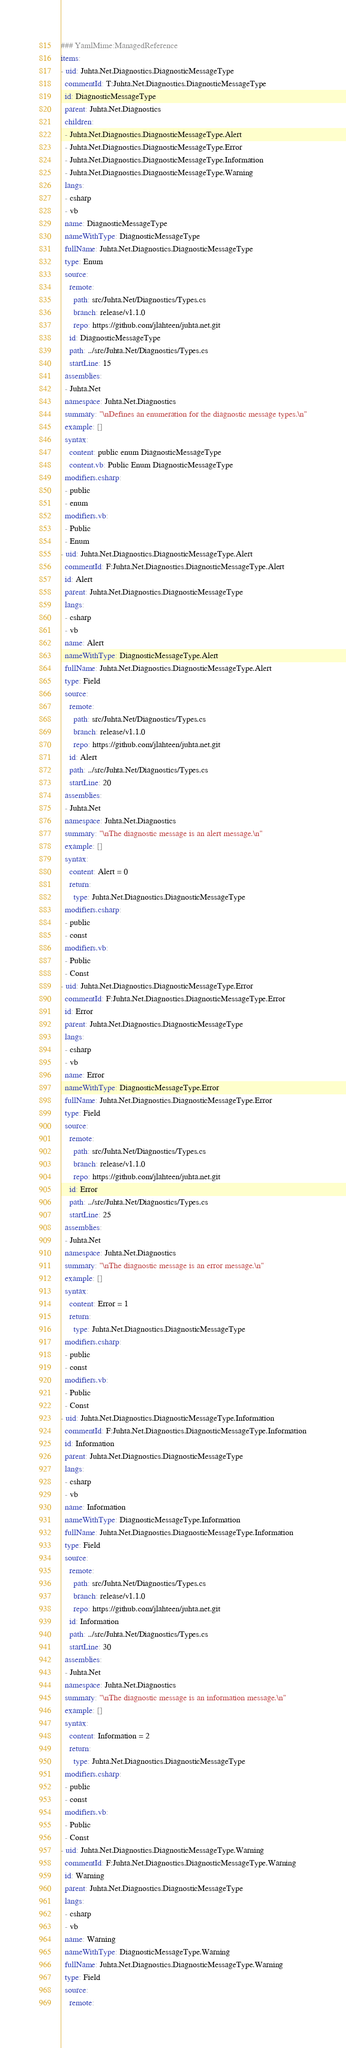<code> <loc_0><loc_0><loc_500><loc_500><_YAML_>### YamlMime:ManagedReference
items:
- uid: Juhta.Net.Diagnostics.DiagnosticMessageType
  commentId: T:Juhta.Net.Diagnostics.DiagnosticMessageType
  id: DiagnosticMessageType
  parent: Juhta.Net.Diagnostics
  children:
  - Juhta.Net.Diagnostics.DiagnosticMessageType.Alert
  - Juhta.Net.Diagnostics.DiagnosticMessageType.Error
  - Juhta.Net.Diagnostics.DiagnosticMessageType.Information
  - Juhta.Net.Diagnostics.DiagnosticMessageType.Warning
  langs:
  - csharp
  - vb
  name: DiagnosticMessageType
  nameWithType: DiagnosticMessageType
  fullName: Juhta.Net.Diagnostics.DiagnosticMessageType
  type: Enum
  source:
    remote:
      path: src/Juhta.Net/Diagnostics/Types.cs
      branch: release/v1.1.0
      repo: https://github.com/jlahteen/juhta.net.git
    id: DiagnosticMessageType
    path: ../src/Juhta.Net/Diagnostics/Types.cs
    startLine: 15
  assemblies:
  - Juhta.Net
  namespace: Juhta.Net.Diagnostics
  summary: "\nDefines an enumeration for the diagnostic message types.\n"
  example: []
  syntax:
    content: public enum DiagnosticMessageType
    content.vb: Public Enum DiagnosticMessageType
  modifiers.csharp:
  - public
  - enum
  modifiers.vb:
  - Public
  - Enum
- uid: Juhta.Net.Diagnostics.DiagnosticMessageType.Alert
  commentId: F:Juhta.Net.Diagnostics.DiagnosticMessageType.Alert
  id: Alert
  parent: Juhta.Net.Diagnostics.DiagnosticMessageType
  langs:
  - csharp
  - vb
  name: Alert
  nameWithType: DiagnosticMessageType.Alert
  fullName: Juhta.Net.Diagnostics.DiagnosticMessageType.Alert
  type: Field
  source:
    remote:
      path: src/Juhta.Net/Diagnostics/Types.cs
      branch: release/v1.1.0
      repo: https://github.com/jlahteen/juhta.net.git
    id: Alert
    path: ../src/Juhta.Net/Diagnostics/Types.cs
    startLine: 20
  assemblies:
  - Juhta.Net
  namespace: Juhta.Net.Diagnostics
  summary: "\nThe diagnostic message is an alert message.\n"
  example: []
  syntax:
    content: Alert = 0
    return:
      type: Juhta.Net.Diagnostics.DiagnosticMessageType
  modifiers.csharp:
  - public
  - const
  modifiers.vb:
  - Public
  - Const
- uid: Juhta.Net.Diagnostics.DiagnosticMessageType.Error
  commentId: F:Juhta.Net.Diagnostics.DiagnosticMessageType.Error
  id: Error
  parent: Juhta.Net.Diagnostics.DiagnosticMessageType
  langs:
  - csharp
  - vb
  name: Error
  nameWithType: DiagnosticMessageType.Error
  fullName: Juhta.Net.Diagnostics.DiagnosticMessageType.Error
  type: Field
  source:
    remote:
      path: src/Juhta.Net/Diagnostics/Types.cs
      branch: release/v1.1.0
      repo: https://github.com/jlahteen/juhta.net.git
    id: Error
    path: ../src/Juhta.Net/Diagnostics/Types.cs
    startLine: 25
  assemblies:
  - Juhta.Net
  namespace: Juhta.Net.Diagnostics
  summary: "\nThe diagnostic message is an error message.\n"
  example: []
  syntax:
    content: Error = 1
    return:
      type: Juhta.Net.Diagnostics.DiagnosticMessageType
  modifiers.csharp:
  - public
  - const
  modifiers.vb:
  - Public
  - Const
- uid: Juhta.Net.Diagnostics.DiagnosticMessageType.Information
  commentId: F:Juhta.Net.Diagnostics.DiagnosticMessageType.Information
  id: Information
  parent: Juhta.Net.Diagnostics.DiagnosticMessageType
  langs:
  - csharp
  - vb
  name: Information
  nameWithType: DiagnosticMessageType.Information
  fullName: Juhta.Net.Diagnostics.DiagnosticMessageType.Information
  type: Field
  source:
    remote:
      path: src/Juhta.Net/Diagnostics/Types.cs
      branch: release/v1.1.0
      repo: https://github.com/jlahteen/juhta.net.git
    id: Information
    path: ../src/Juhta.Net/Diagnostics/Types.cs
    startLine: 30
  assemblies:
  - Juhta.Net
  namespace: Juhta.Net.Diagnostics
  summary: "\nThe diagnostic message is an information message.\n"
  example: []
  syntax:
    content: Information = 2
    return:
      type: Juhta.Net.Diagnostics.DiagnosticMessageType
  modifiers.csharp:
  - public
  - const
  modifiers.vb:
  - Public
  - Const
- uid: Juhta.Net.Diagnostics.DiagnosticMessageType.Warning
  commentId: F:Juhta.Net.Diagnostics.DiagnosticMessageType.Warning
  id: Warning
  parent: Juhta.Net.Diagnostics.DiagnosticMessageType
  langs:
  - csharp
  - vb
  name: Warning
  nameWithType: DiagnosticMessageType.Warning
  fullName: Juhta.Net.Diagnostics.DiagnosticMessageType.Warning
  type: Field
  source:
    remote:</code> 